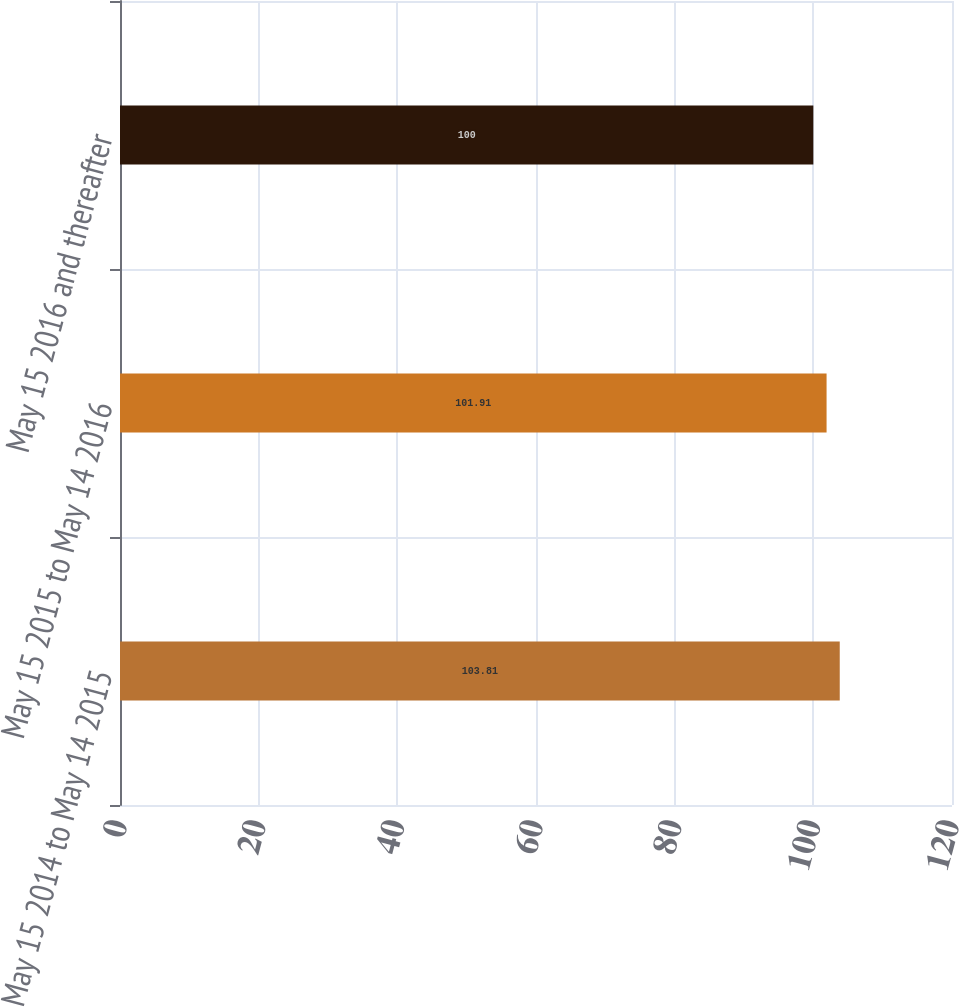Convert chart to OTSL. <chart><loc_0><loc_0><loc_500><loc_500><bar_chart><fcel>May 15 2014 to May 14 2015<fcel>May 15 2015 to May 14 2016<fcel>May 15 2016 and thereafter<nl><fcel>103.81<fcel>101.91<fcel>100<nl></chart> 